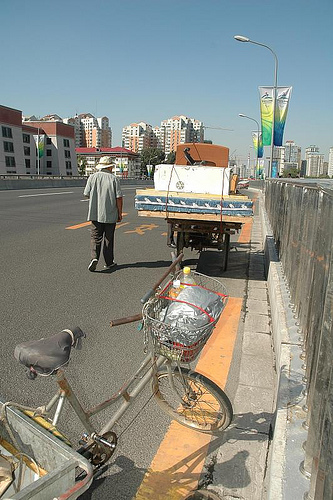<image>
Is there a man on the bike? No. The man is not positioned on the bike. They may be near each other, but the man is not supported by or resting on top of the bike. 